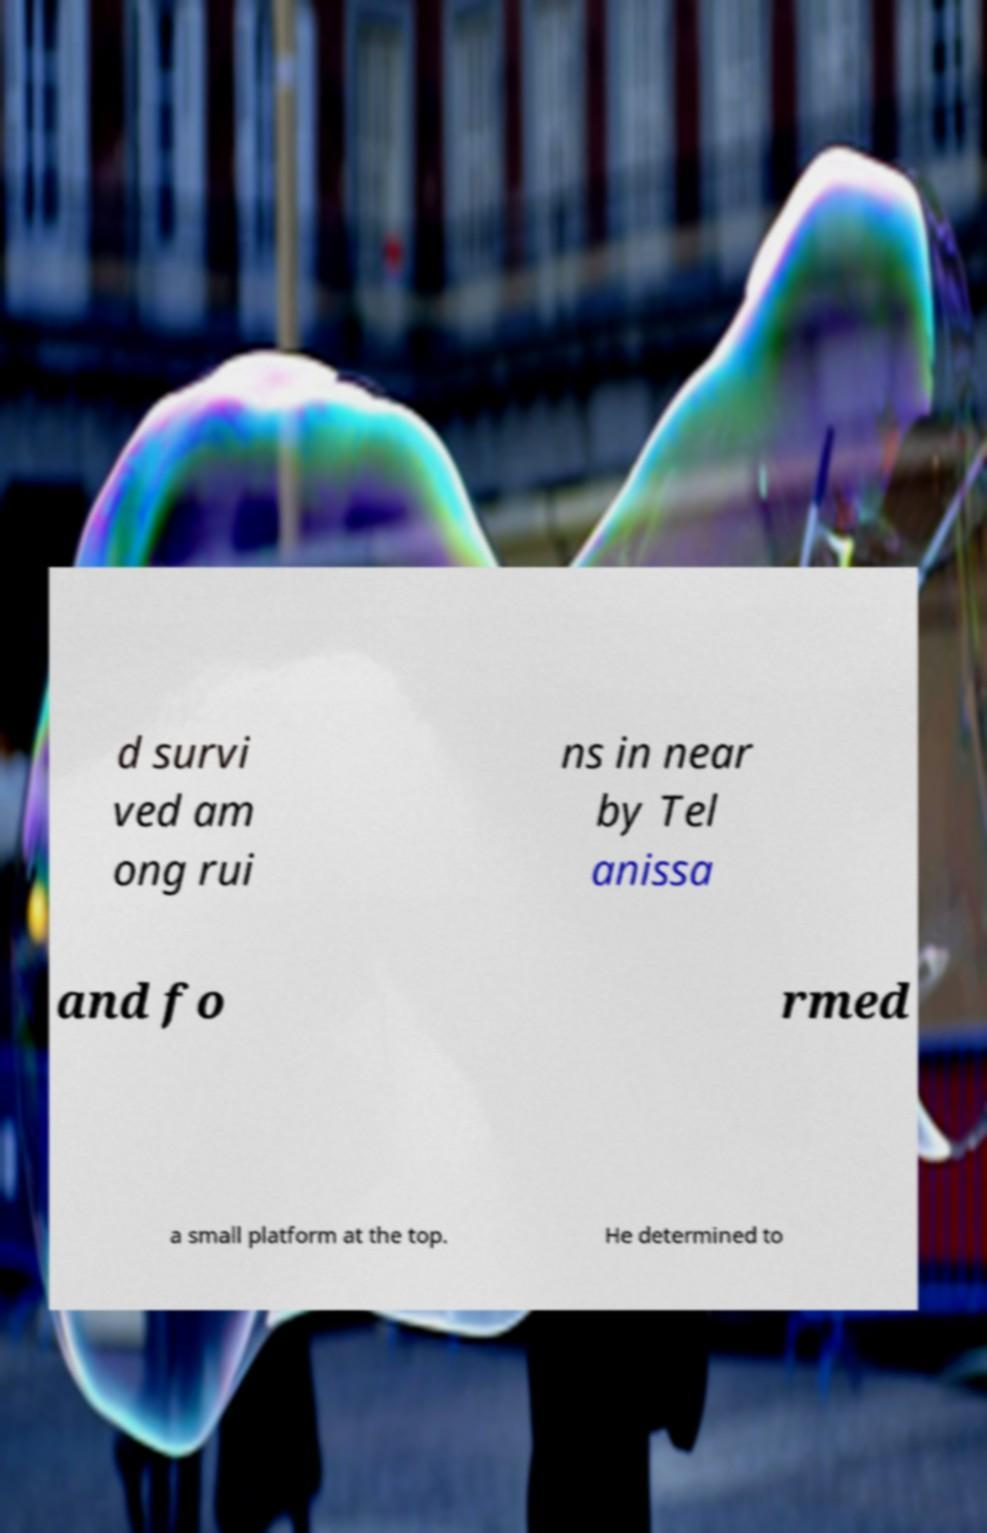Could you assist in decoding the text presented in this image and type it out clearly? d survi ved am ong rui ns in near by Tel anissa and fo rmed a small platform at the top. He determined to 